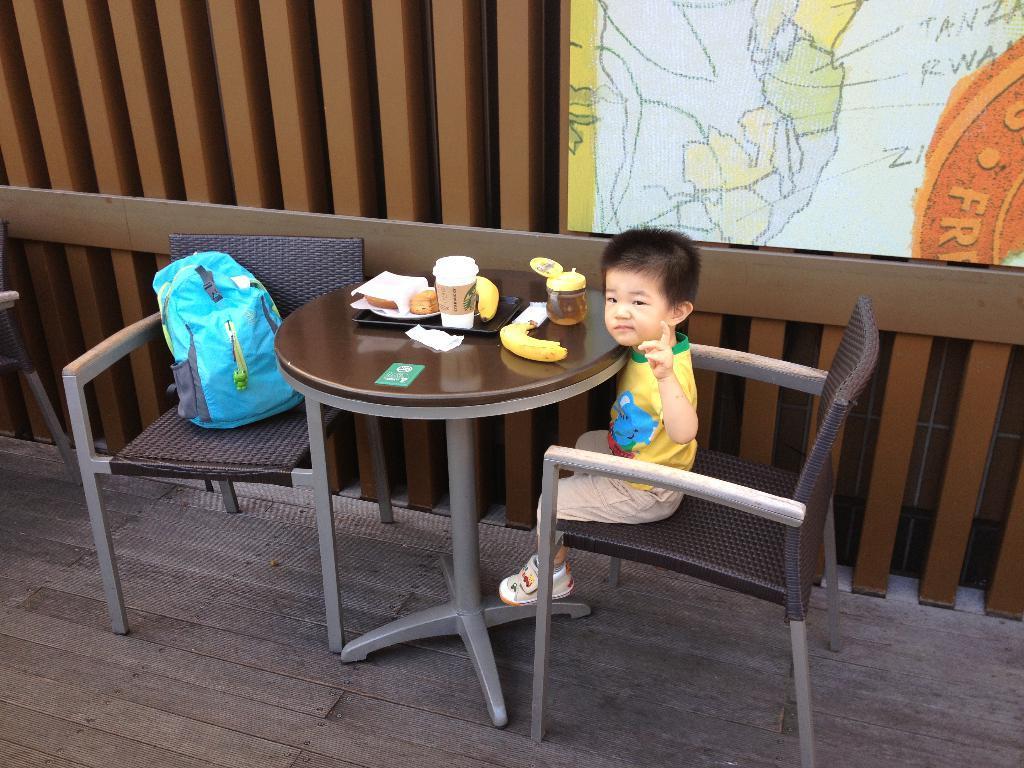Please provide a concise description of this image. In this image we can see a boy sitting on the chair, in front of him we can see a table, on the table, we can see some bananas, tissue paper, glass and other objects, also we can see a chair with a bag on it, in the background we can see the wall, on the wall there is a poster. 